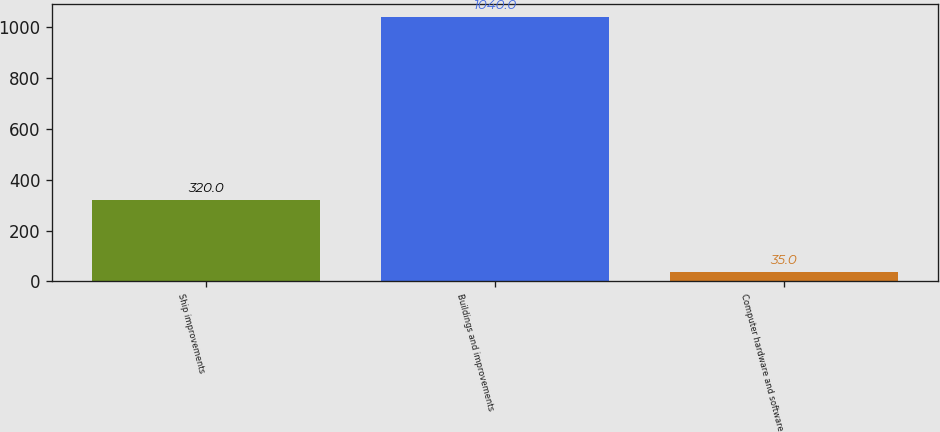Convert chart. <chart><loc_0><loc_0><loc_500><loc_500><bar_chart><fcel>Ship improvements<fcel>Buildings and improvements<fcel>Computer hardware and software<nl><fcel>320<fcel>1040<fcel>35<nl></chart> 